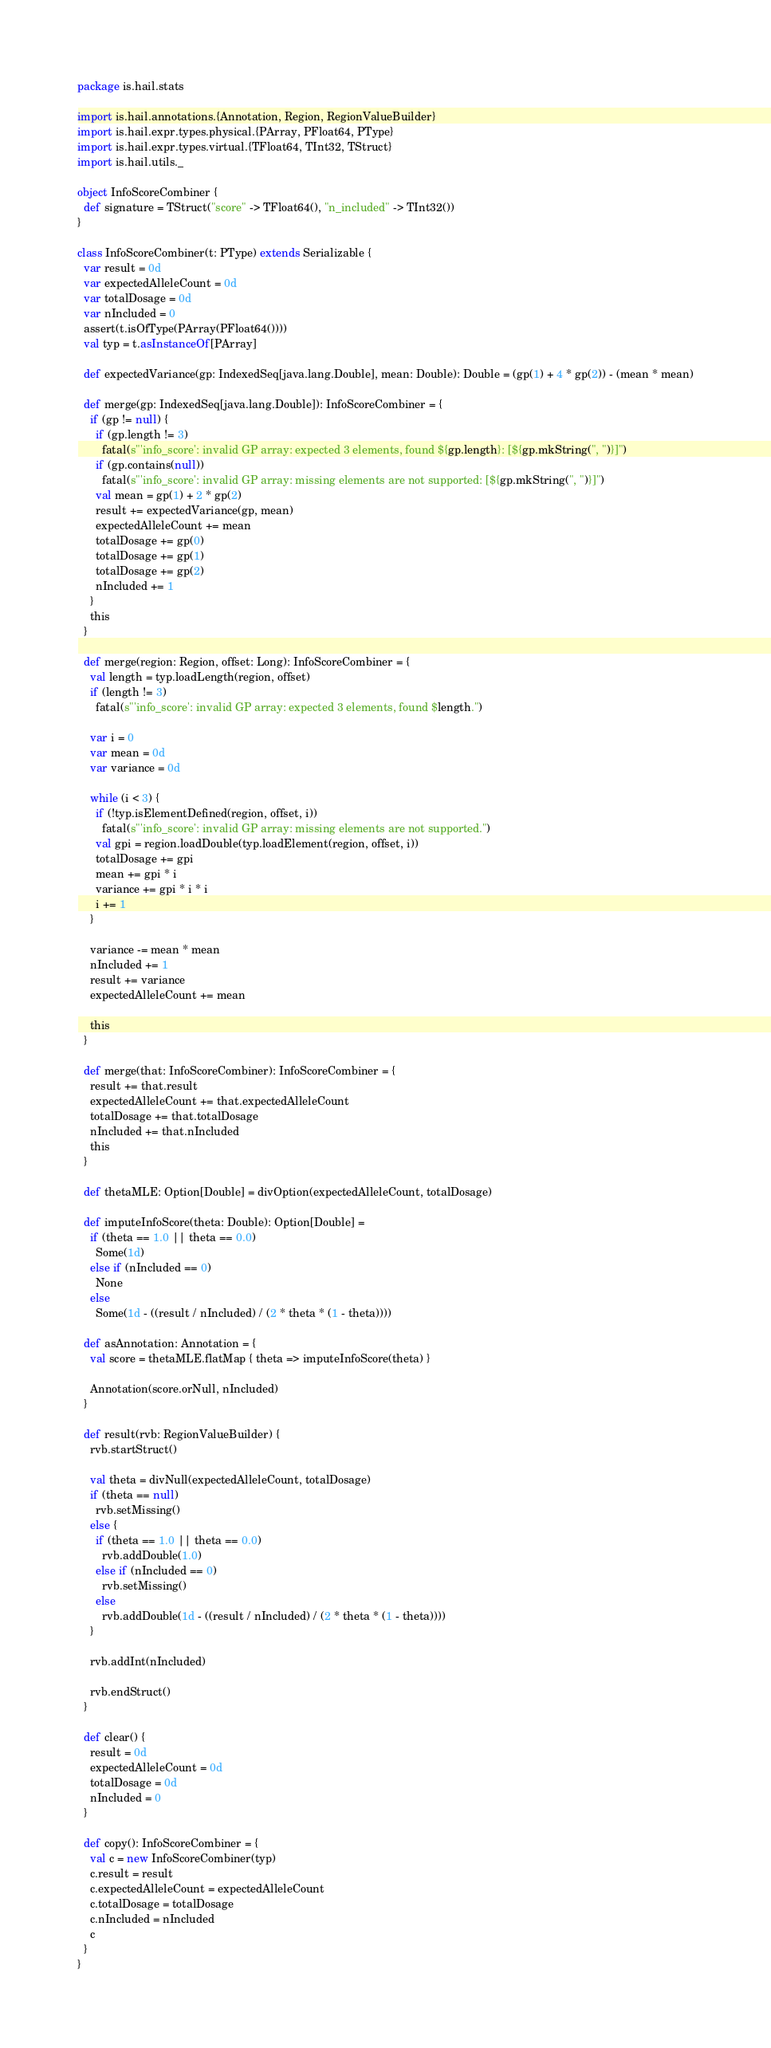<code> <loc_0><loc_0><loc_500><loc_500><_Scala_>package is.hail.stats

import is.hail.annotations.{Annotation, Region, RegionValueBuilder}
import is.hail.expr.types.physical.{PArray, PFloat64, PType}
import is.hail.expr.types.virtual.{TFloat64, TInt32, TStruct}
import is.hail.utils._

object InfoScoreCombiner {
  def signature = TStruct("score" -> TFloat64(), "n_included" -> TInt32())
}

class InfoScoreCombiner(t: PType) extends Serializable {
  var result = 0d
  var expectedAlleleCount = 0d
  var totalDosage = 0d
  var nIncluded = 0
  assert(t.isOfType(PArray(PFloat64())))
  val typ = t.asInstanceOf[PArray]

  def expectedVariance(gp: IndexedSeq[java.lang.Double], mean: Double): Double = (gp(1) + 4 * gp(2)) - (mean * mean)

  def merge(gp: IndexedSeq[java.lang.Double]): InfoScoreCombiner = {
    if (gp != null) {
      if (gp.length != 3)
        fatal(s"'info_score': invalid GP array: expected 3 elements, found ${gp.length}: [${gp.mkString(", ")}]")
      if (gp.contains(null))
        fatal(s"'info_score': invalid GP array: missing elements are not supported: [${gp.mkString(", ")}]")
      val mean = gp(1) + 2 * gp(2)
      result += expectedVariance(gp, mean)
      expectedAlleleCount += mean
      totalDosage += gp(0)
      totalDosage += gp(1)
      totalDosage += gp(2)
      nIncluded += 1
    }
    this
  }

  def merge(region: Region, offset: Long): InfoScoreCombiner = {
    val length = typ.loadLength(region, offset)
    if (length != 3)
      fatal(s"'info_score': invalid GP array: expected 3 elements, found $length.")

    var i = 0
    var mean = 0d
    var variance = 0d

    while (i < 3) {
      if (!typ.isElementDefined(region, offset, i))
        fatal(s"'info_score': invalid GP array: missing elements are not supported.")
      val gpi = region.loadDouble(typ.loadElement(region, offset, i))
      totalDosage += gpi
      mean += gpi * i
      variance += gpi * i * i
      i += 1
    }

    variance -= mean * mean
    nIncluded += 1
    result += variance
    expectedAlleleCount += mean

    this
  }

  def merge(that: InfoScoreCombiner): InfoScoreCombiner = {
    result += that.result
    expectedAlleleCount += that.expectedAlleleCount
    totalDosage += that.totalDosage
    nIncluded += that.nIncluded
    this
  }

  def thetaMLE: Option[Double] = divOption(expectedAlleleCount, totalDosage)

  def imputeInfoScore(theta: Double): Option[Double] =
    if (theta == 1.0 || theta == 0.0)
      Some(1d)
    else if (nIncluded == 0)
      None
    else
      Some(1d - ((result / nIncluded) / (2 * theta * (1 - theta))))

  def asAnnotation: Annotation = {
    val score = thetaMLE.flatMap { theta => imputeInfoScore(theta) }

    Annotation(score.orNull, nIncluded)
  }

  def result(rvb: RegionValueBuilder) {
    rvb.startStruct()

    val theta = divNull(expectedAlleleCount, totalDosage)
    if (theta == null)
      rvb.setMissing()
    else {
      if (theta == 1.0 || theta == 0.0)
        rvb.addDouble(1.0)
      else if (nIncluded == 0)
        rvb.setMissing()
      else
        rvb.addDouble(1d - ((result / nIncluded) / (2 * theta * (1 - theta))))
    }

    rvb.addInt(nIncluded)

    rvb.endStruct()
  }

  def clear() {
    result = 0d
    expectedAlleleCount = 0d
    totalDosage = 0d
    nIncluded = 0
  }

  def copy(): InfoScoreCombiner = {
    val c = new InfoScoreCombiner(typ)
    c.result = result
    c.expectedAlleleCount = expectedAlleleCount
    c.totalDosage = totalDosage
    c.nIncluded = nIncluded
    c
  }
}
</code> 